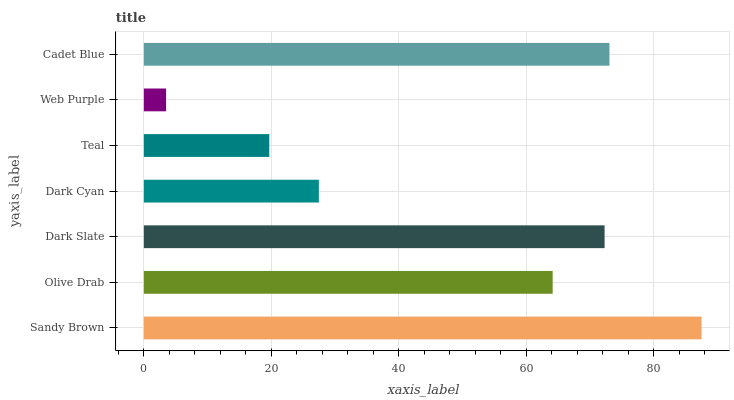Is Web Purple the minimum?
Answer yes or no. Yes. Is Sandy Brown the maximum?
Answer yes or no. Yes. Is Olive Drab the minimum?
Answer yes or no. No. Is Olive Drab the maximum?
Answer yes or no. No. Is Sandy Brown greater than Olive Drab?
Answer yes or no. Yes. Is Olive Drab less than Sandy Brown?
Answer yes or no. Yes. Is Olive Drab greater than Sandy Brown?
Answer yes or no. No. Is Sandy Brown less than Olive Drab?
Answer yes or no. No. Is Olive Drab the high median?
Answer yes or no. Yes. Is Olive Drab the low median?
Answer yes or no. Yes. Is Sandy Brown the high median?
Answer yes or no. No. Is Teal the low median?
Answer yes or no. No. 